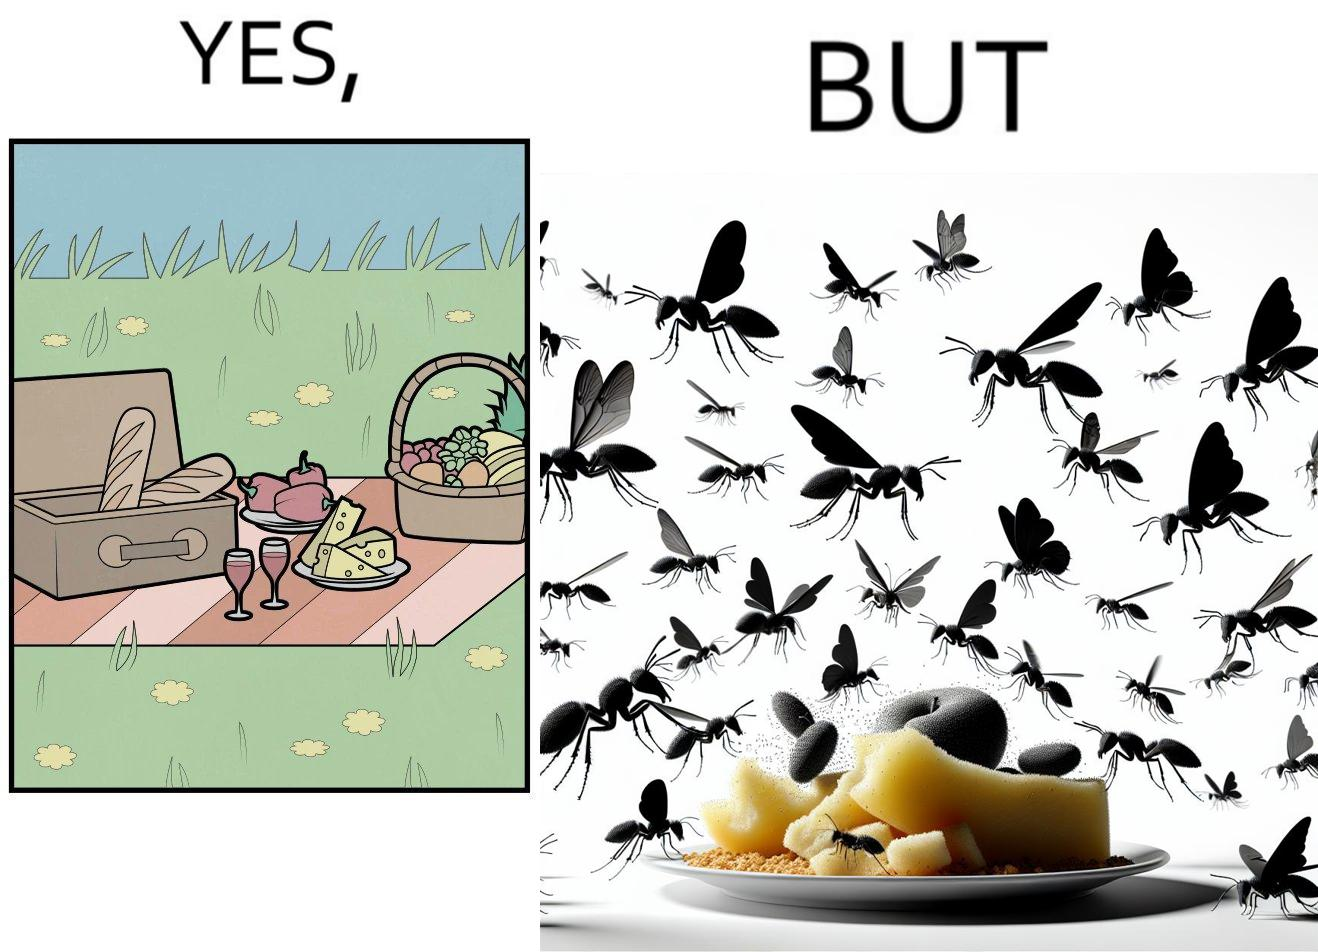What do you see in each half of this image? In the left part of the image: The food is kept on a blanket in a garden. In the right part of the image: Some bugs are attracting towards the food. 